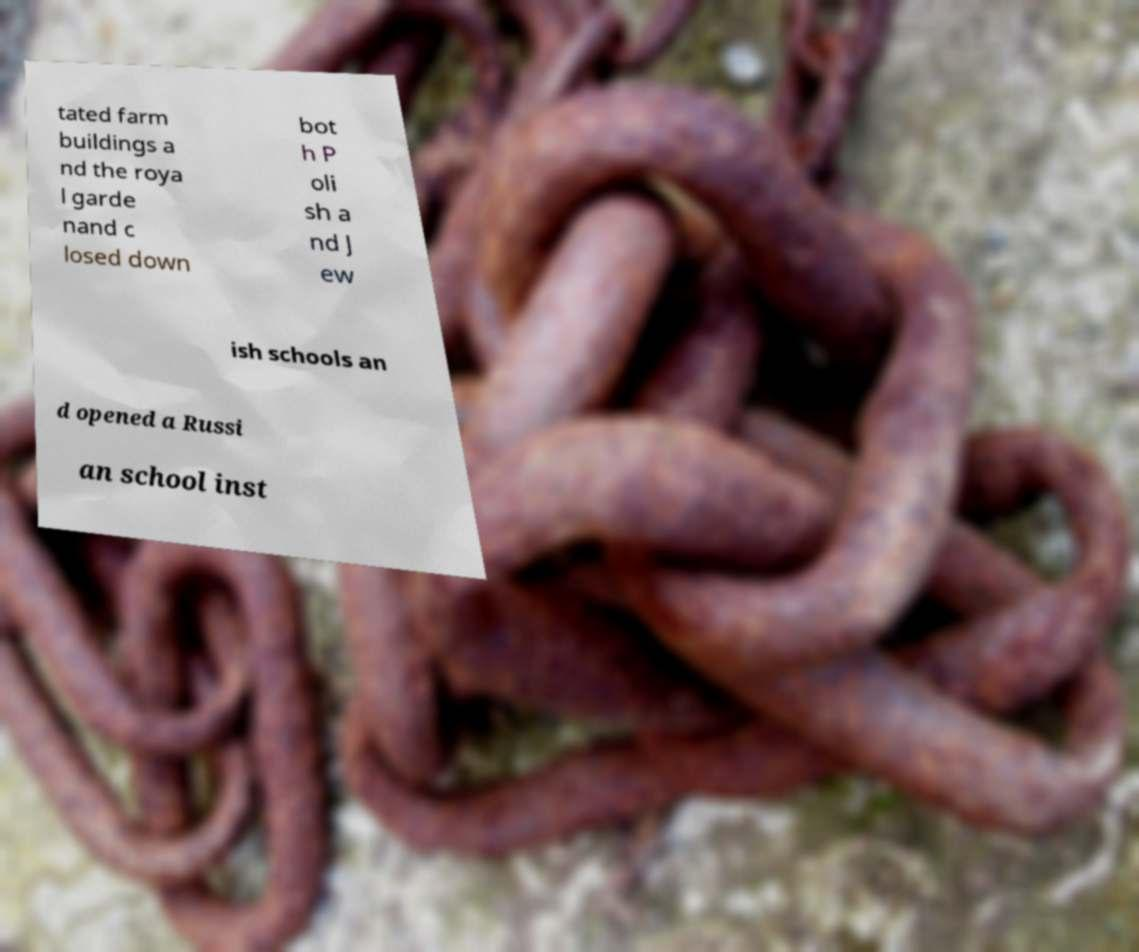Please identify and transcribe the text found in this image. tated farm buildings a nd the roya l garde nand c losed down bot h P oli sh a nd J ew ish schools an d opened a Russi an school inst 